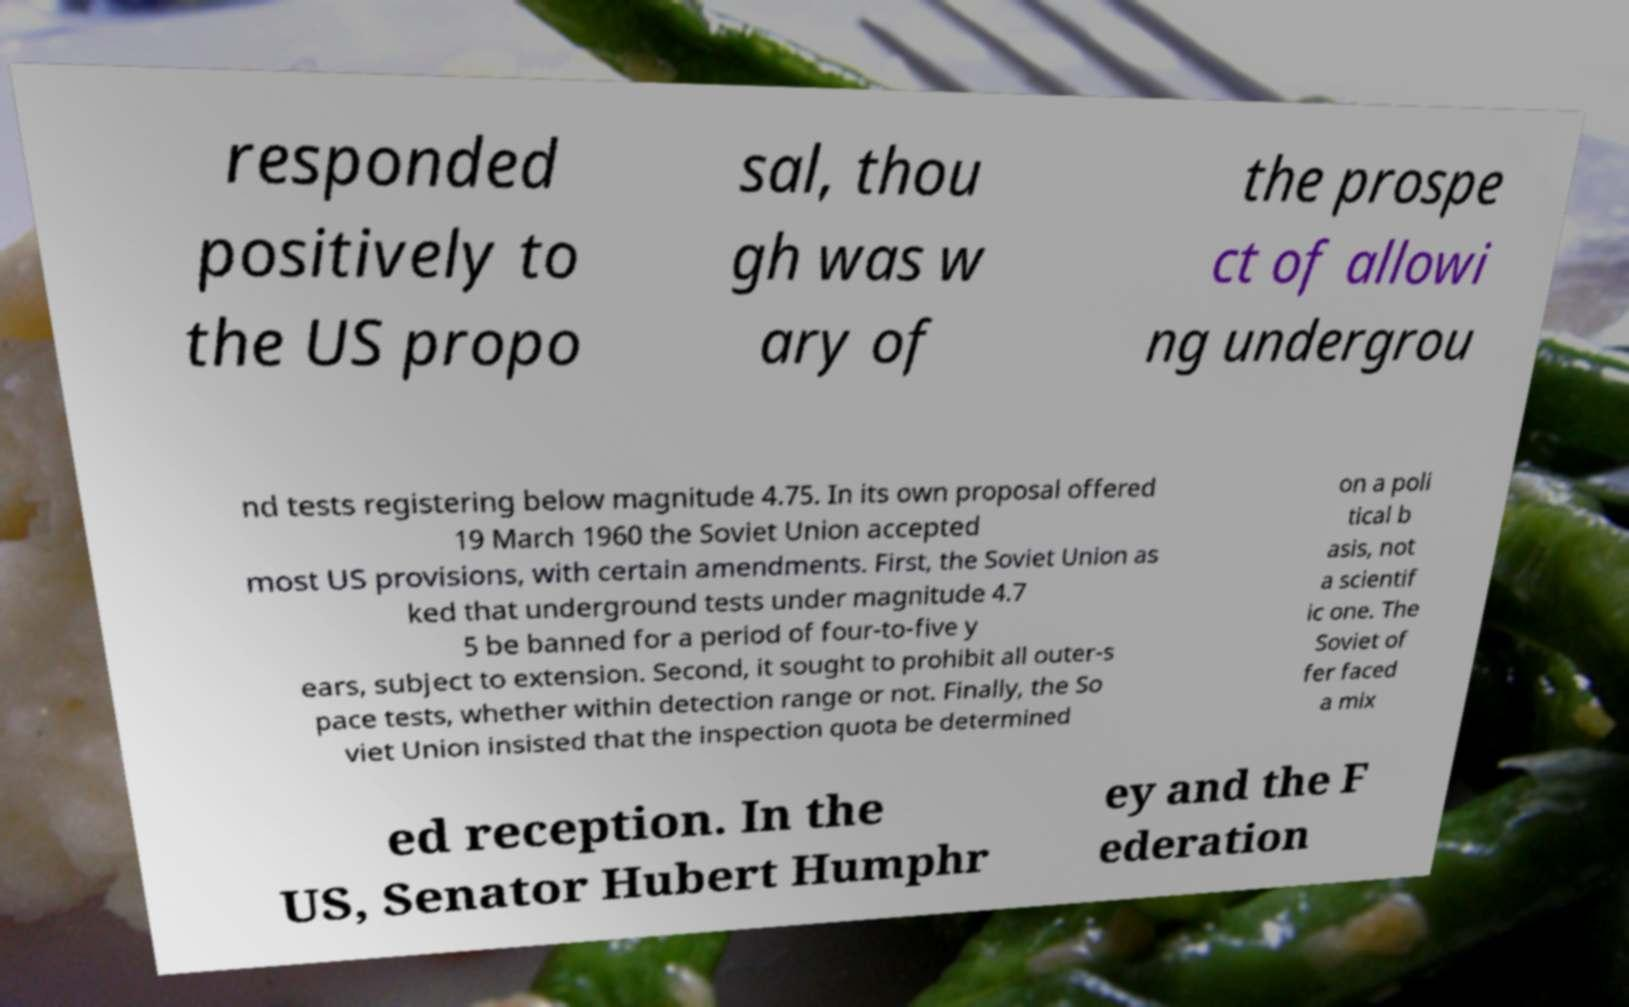Please identify and transcribe the text found in this image. responded positively to the US propo sal, thou gh was w ary of the prospe ct of allowi ng undergrou nd tests registering below magnitude 4.75. In its own proposal offered 19 March 1960 the Soviet Union accepted most US provisions, with certain amendments. First, the Soviet Union as ked that underground tests under magnitude 4.7 5 be banned for a period of four-to-five y ears, subject to extension. Second, it sought to prohibit all outer-s pace tests, whether within detection range or not. Finally, the So viet Union insisted that the inspection quota be determined on a poli tical b asis, not a scientif ic one. The Soviet of fer faced a mix ed reception. In the US, Senator Hubert Humphr ey and the F ederation 